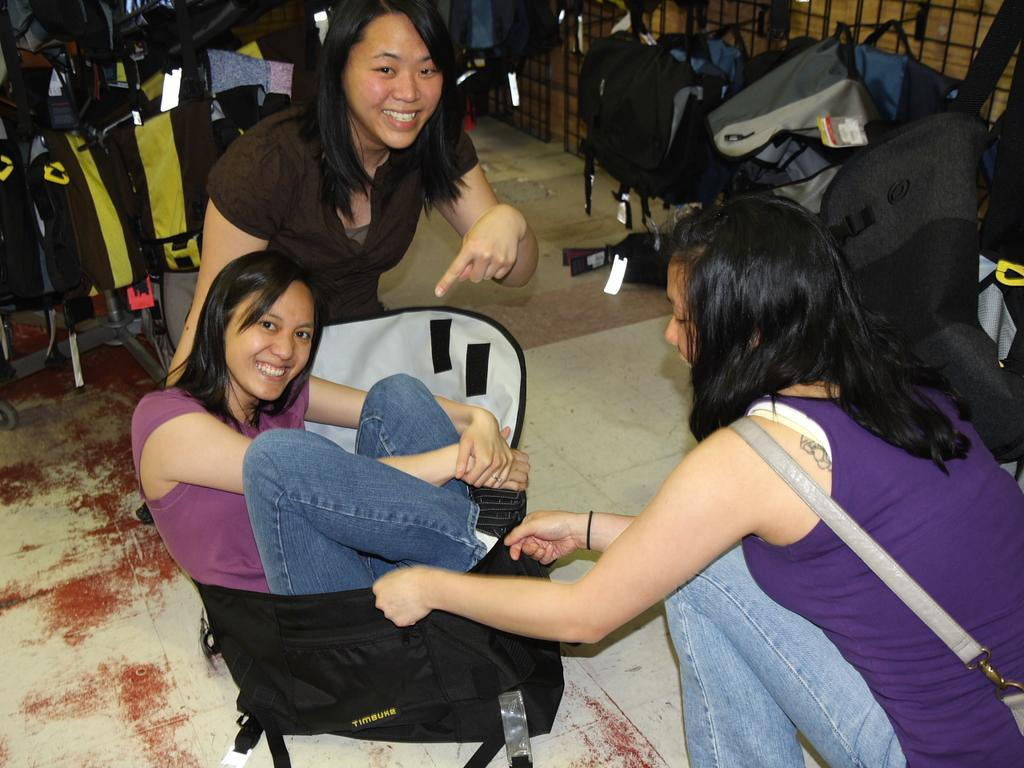How many women are in the image? There are three women in the image. What is the facial expression of the women? The women are smiling. What is the position of one of the women in the image? One woman is seated in a bag. What objects can be seen in the image besides the women? There are bags and metal rods visible in the image. What type of boundary can be seen in the image? There is no boundary present in the image. What is the weight of the metal rods in the image? The weight of the metal rods cannot be determined from the image alone. 